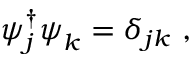Convert formula to latex. <formula><loc_0><loc_0><loc_500><loc_500>\psi _ { j } ^ { \dagger } \psi _ { k } = \delta _ { j k } ,</formula> 